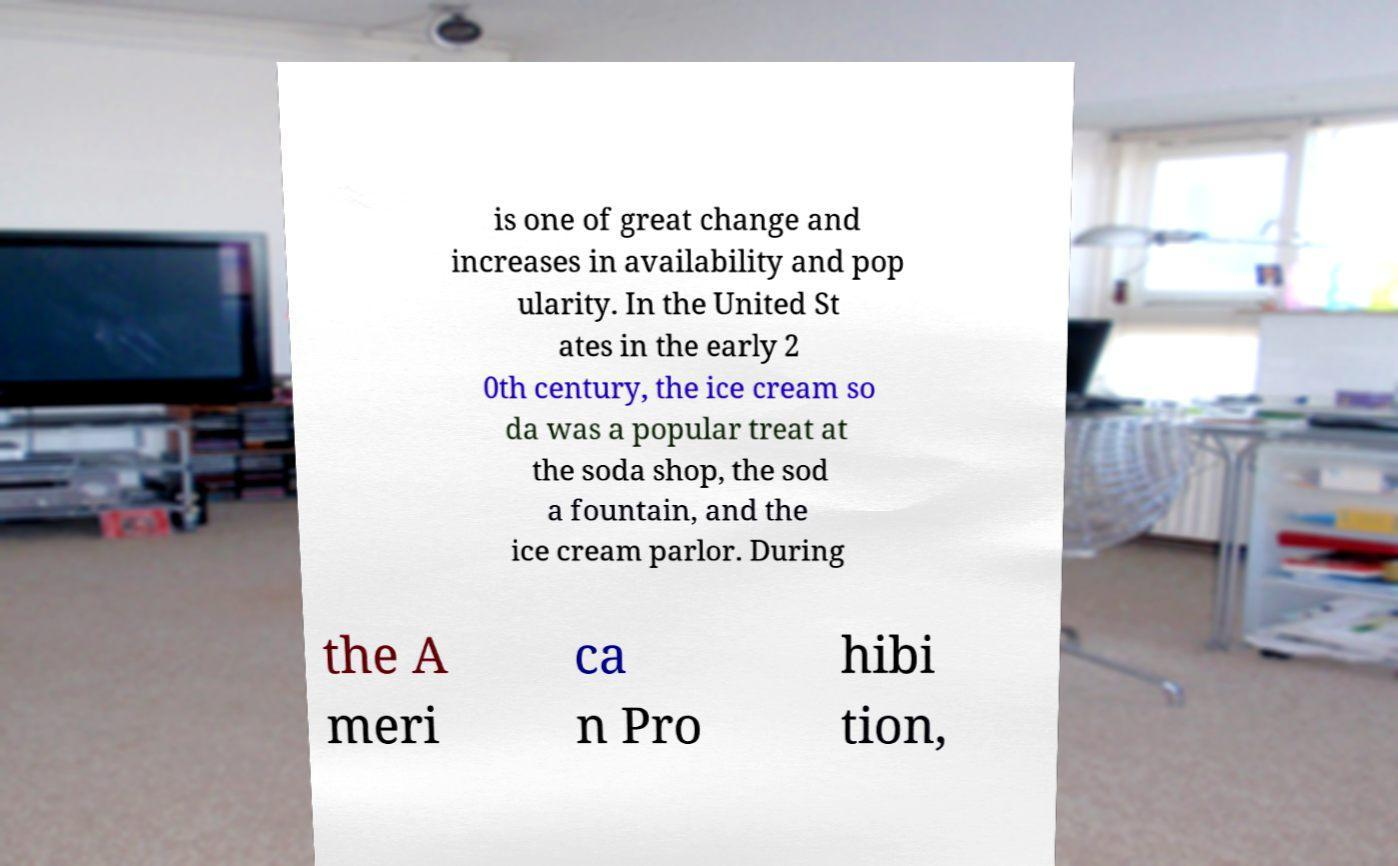For documentation purposes, I need the text within this image transcribed. Could you provide that? is one of great change and increases in availability and pop ularity. In the United St ates in the early 2 0th century, the ice cream so da was a popular treat at the soda shop, the sod a fountain, and the ice cream parlor. During the A meri ca n Pro hibi tion, 